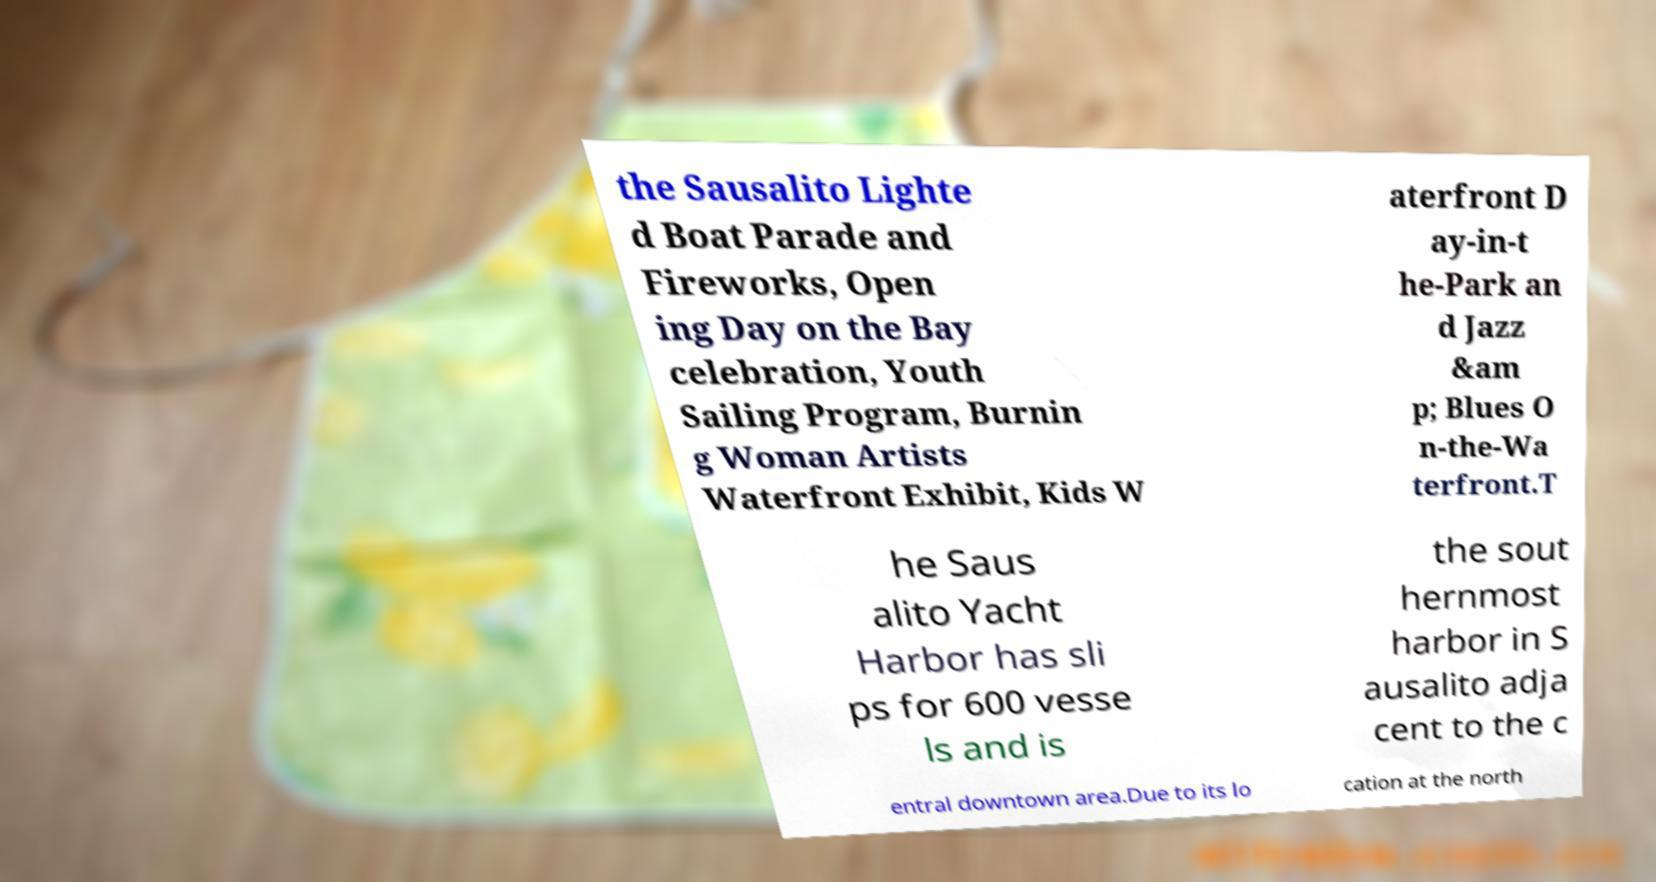There's text embedded in this image that I need extracted. Can you transcribe it verbatim? the Sausalito Lighte d Boat Parade and Fireworks, Open ing Day on the Bay celebration, Youth Sailing Program, Burnin g Woman Artists Waterfront Exhibit, Kids W aterfront D ay-in-t he-Park an d Jazz &am p; Blues O n-the-Wa terfront.T he Saus alito Yacht Harbor has sli ps for 600 vesse ls and is the sout hernmost harbor in S ausalito adja cent to the c entral downtown area.Due to its lo cation at the north 